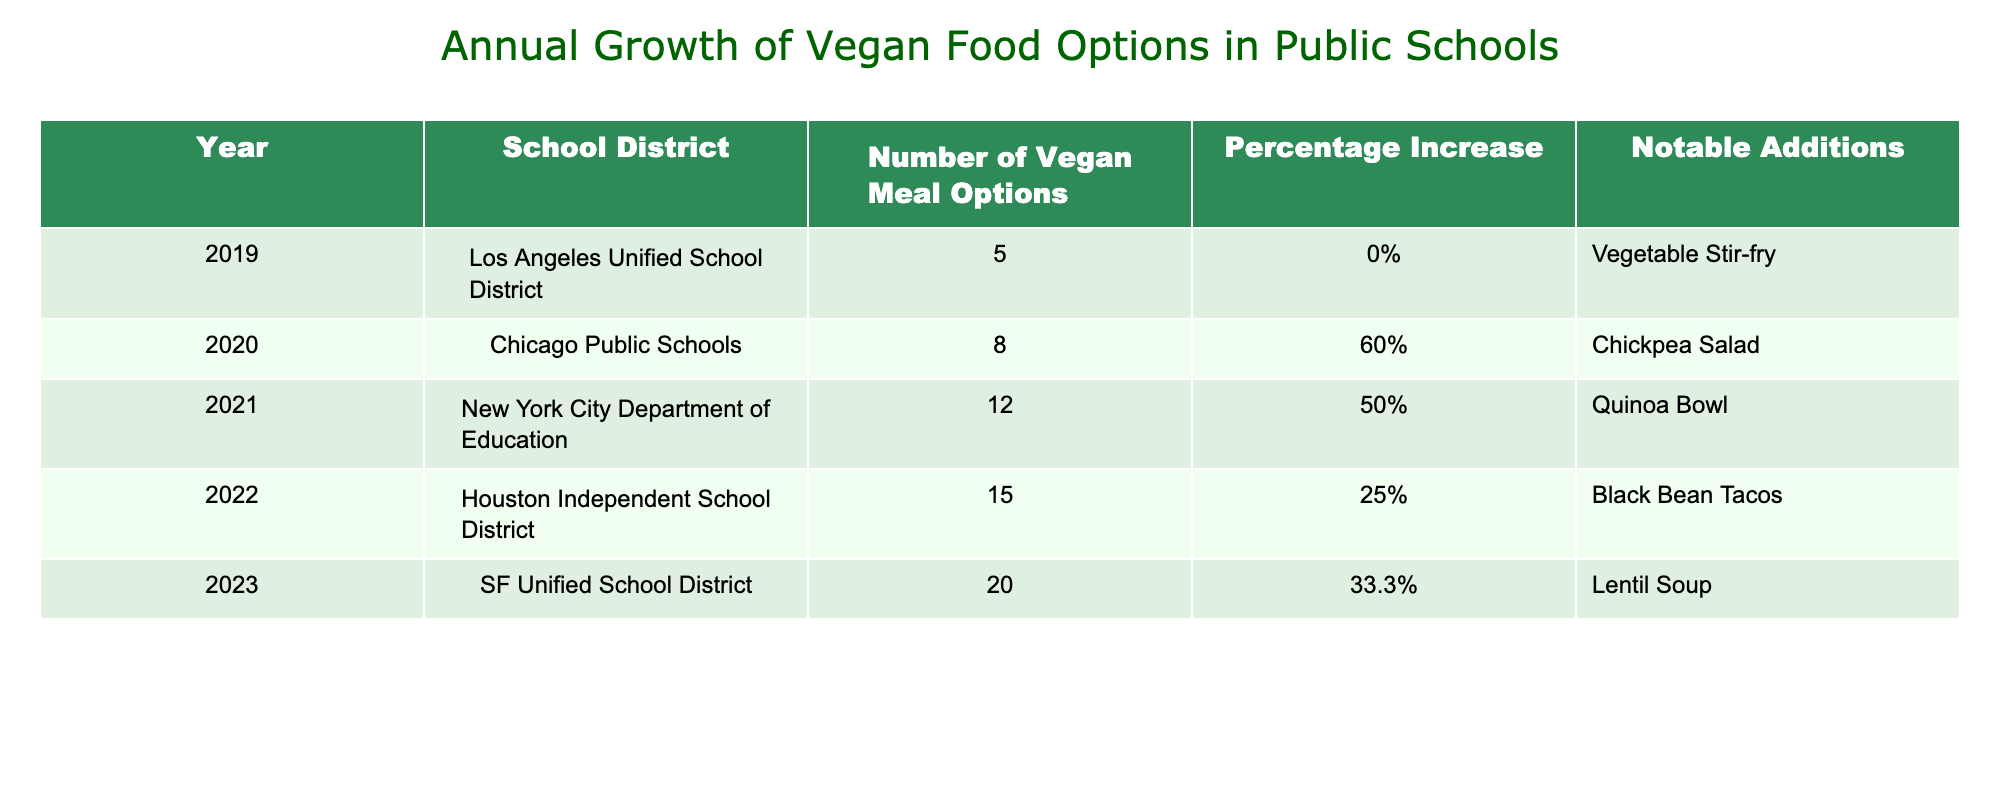What was the total number of vegan meal options offered across all the years provided? To find the total number of vegan meal options, I will sum the values from the "Number of Vegan Meal Options" column: 5 (2019) + 8 (2020) + 12 (2021) + 15 (2022) + 20 (2023) = 60.
Answer: 60 Which school district had the highest number of vegan meal options in 2023? Looking at the "Number of Vegan Meal Options" for 2023, SF Unified School District is noted to have 20 options, which is the highest across all the years listed.
Answer: SF Unified School District Was there a year when the number of vegan meal options did not increase? Referring to the table, in 2019, the percentage increase is 0%, indicating there was no increase in the number of vegan options that year.
Answer: Yes What was the average percentage increase of vegan meal options from 2019 to 2023? To find the average percentage increase, I will take the percentages from each year (0%, 60%, 50%, 25%, 33.3%) and sum them: 0 + 60 + 50 + 25 + 33.3 = 168.3. There are 5 years, so the average is 168.3/5 = 33.66%.
Answer: 33.66% Which notable addition came in 2021? In 2021, the notable addition to the vegan meal options was the Quinoa Bowl, as stated in the "Notable Additions" column for that year.
Answer: Quinoa Bowl What was the percentage increase of vegan meal options from 2021 to 2022? The number of vegan meal options in 2021 was 12 and in 2022 was 15. The percentage increase is calculated as (15 - 12) / 12 * 100 = 25%.
Answer: 25% Did the number of vegan meal options double within the five-year span? The number of vegan meal options increased from 5 in 2019 to 20 in 2023. Since 20 is not double 5 (which would be 10), the claim of doubling the options is false.
Answer: No Which school district had a notable addition of Black Bean Tacos? The notable addition of Black Bean Tacos occurred in 2022, which is associated with the Houston Independent School District according to the table.
Answer: Houston Independent School District What is the difference in the number of vegan meal options between 2020 and 2021? In 2020, there were 8 vegan meal options, and in 2021, there were 12 options. The difference is calculated as 12 - 8 = 4.
Answer: 4 